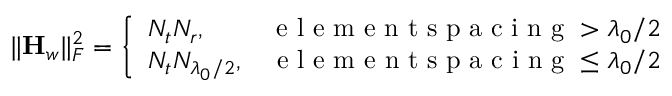Convert formula to latex. <formula><loc_0><loc_0><loc_500><loc_500>\| { H _ { w } } \| _ { F } ^ { 2 } = \left \{ \begin{array} { l r } { N _ { t } N _ { r } , } & { e l e m e n t s p a c i n g > \lambda _ { 0 } / 2 } \\ { N _ { t } N _ { \lambda _ { 0 } / 2 } , } & { e l e m e n t s p a c i n g \leq \lambda _ { 0 } / 2 } \end{array}</formula> 